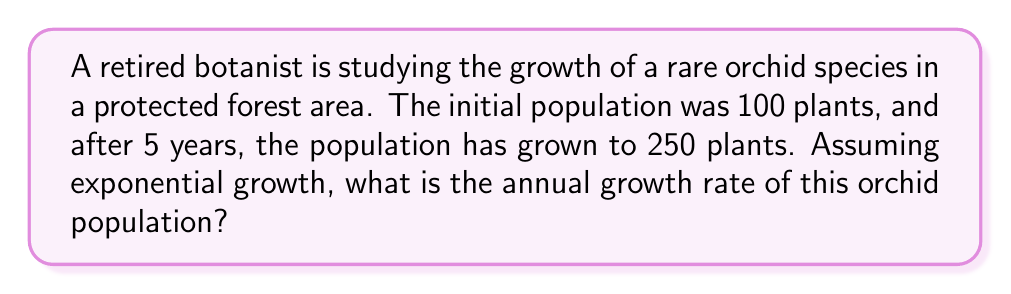Help me with this question. To solve this problem, we'll use the exponential growth formula:

$$A = P(1 + r)^t$$

Where:
$A$ = Final amount
$P$ = Initial amount
$r$ = Annual growth rate
$t$ = Time in years

We know:
$A = 250$ (final population)
$P = 100$ (initial population)
$t = 5$ years

Let's solve for $r$:

1) Substitute the known values into the formula:
   $$250 = 100(1 + r)^5$$

2) Divide both sides by 100:
   $$2.5 = (1 + r)^5$$

3) Take the 5th root of both sides:
   $$\sqrt[5]{2.5} = 1 + r$$

4) Subtract 1 from both sides:
   $$\sqrt[5]{2.5} - 1 = r$$

5) Calculate the value:
   $$r \approx 1.2009 - 1 = 0.2009$$

6) Convert to percentage:
   $$r \approx 0.2009 \times 100\% = 20.09\%$$

Therefore, the annual growth rate is approximately 20.09%.
Answer: 20.09% 